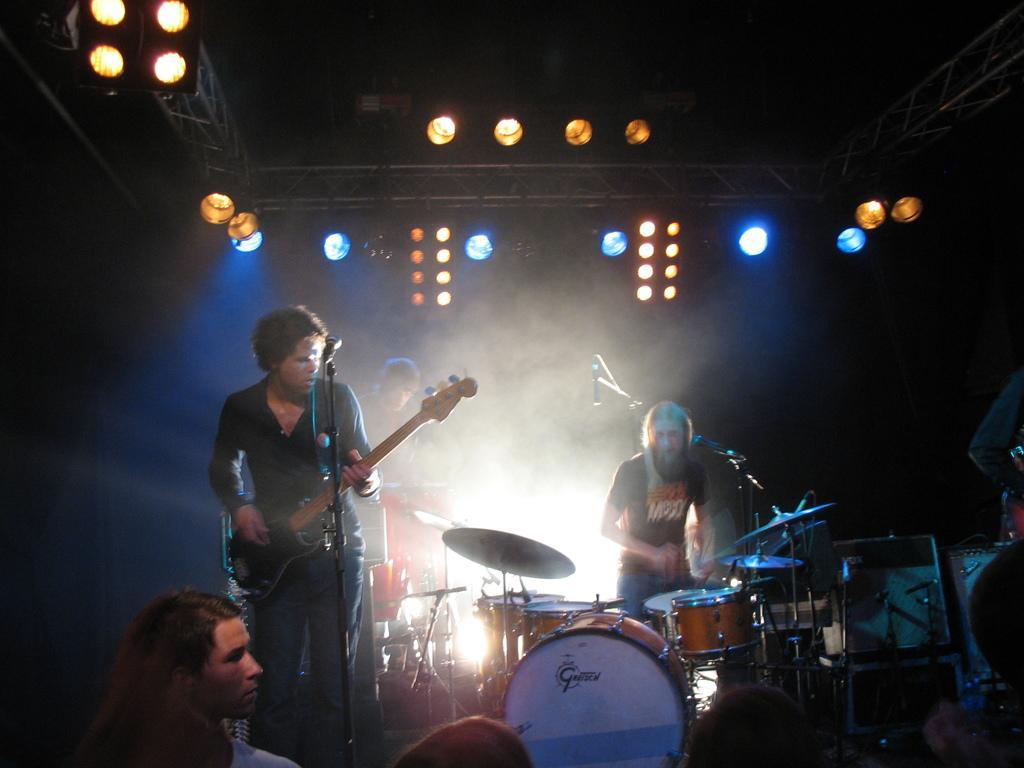Could you give a brief overview of what you see in this image? In this image there is a man standing and playing a guitar , another woman standing and playing drums, another man standing near the drums another person to the left side corner and at back ground there are focus lights and iron rods. 